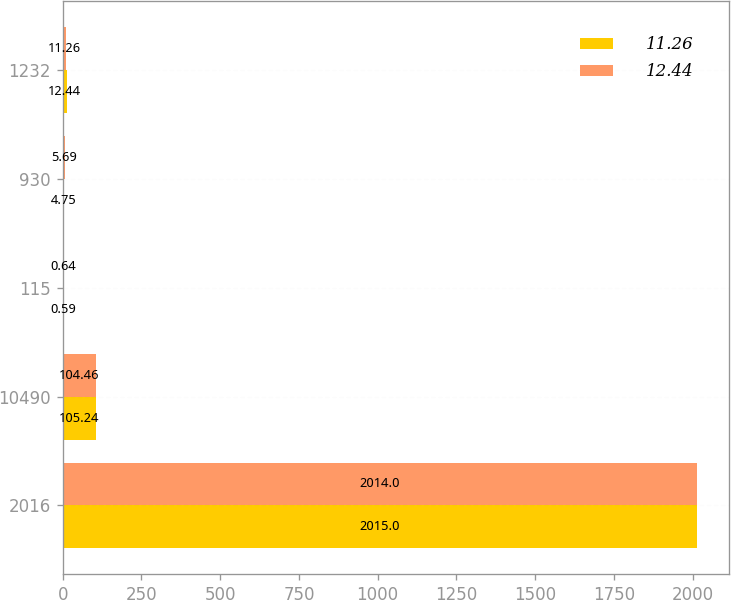<chart> <loc_0><loc_0><loc_500><loc_500><stacked_bar_chart><ecel><fcel>2016<fcel>10490<fcel>115<fcel>930<fcel>1232<nl><fcel>11.26<fcel>2015<fcel>105.24<fcel>0.59<fcel>4.75<fcel>12.44<nl><fcel>12.44<fcel>2014<fcel>104.46<fcel>0.64<fcel>5.69<fcel>11.26<nl></chart> 